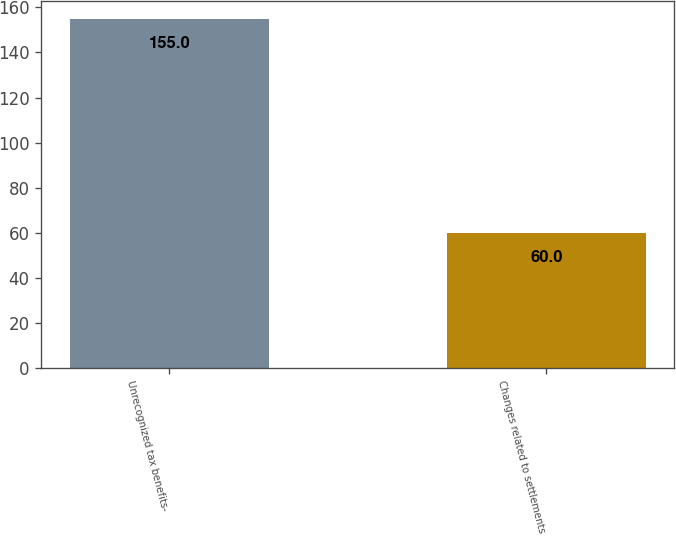Convert chart to OTSL. <chart><loc_0><loc_0><loc_500><loc_500><bar_chart><fcel>Unrecognized tax benefits-<fcel>Changes related to settlements<nl><fcel>155<fcel>60<nl></chart> 